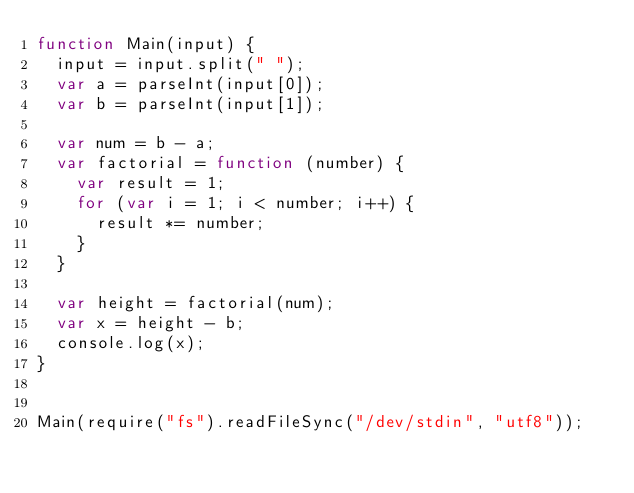<code> <loc_0><loc_0><loc_500><loc_500><_JavaScript_>function Main(input) {
  input = input.split(" ");
  var a = parseInt(input[0]);
  var b = parseInt(input[1]);

  var num = b - a;
  var factorial = function (number) {
    var result = 1;
    for (var i = 1; i < number; i++) {
      result *= number;
    }
  }

  var height = factorial(num);
  var x = height - b;
  console.log(x);
}


Main(require("fs").readFileSync("/dev/stdin", "utf8"));
</code> 